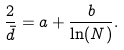<formula> <loc_0><loc_0><loc_500><loc_500>\frac { 2 } { \bar { d } } = a + \frac { b } { \ln ( N ) } .</formula> 